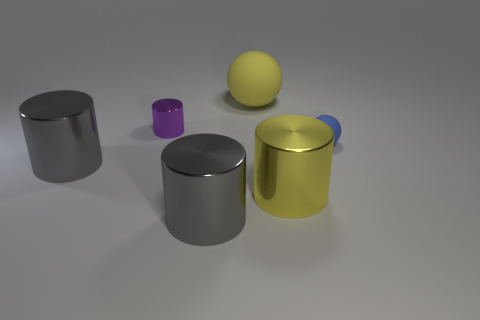Do the cylinder that is on the left side of the purple cylinder and the cylinder behind the blue ball have the same size?
Your response must be concise. No. Are there fewer small cyan shiny balls than cylinders?
Give a very brief answer. Yes. What number of shiny objects are either yellow objects or small cylinders?
Provide a short and direct response. 2. There is a gray object in front of the large yellow shiny cylinder; are there any big metallic objects right of it?
Your answer should be compact. Yes. Do the big gray thing that is in front of the big yellow metal cylinder and the tiny cylinder have the same material?
Make the answer very short. Yes. What number of other objects are the same color as the tiny matte sphere?
Give a very brief answer. 0. Do the big matte thing and the small rubber sphere have the same color?
Offer a terse response. No. There is a shiny cylinder that is right of the big gray metal cylinder on the right side of the purple shiny cylinder; what is its size?
Offer a very short reply. Large. Are the big gray cylinder on the left side of the purple metallic thing and the small object in front of the small purple shiny thing made of the same material?
Ensure brevity in your answer.  No. There is a ball that is on the right side of the yellow rubber object; does it have the same color as the large sphere?
Offer a terse response. No. 